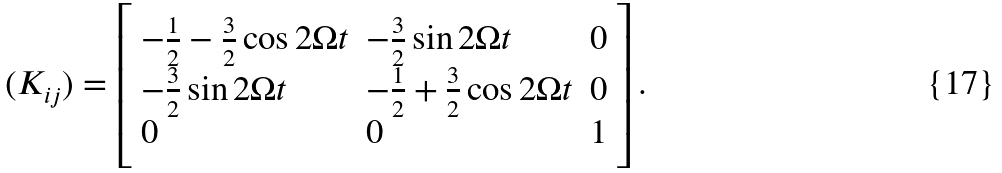<formula> <loc_0><loc_0><loc_500><loc_500>( K _ { i j } ) = \left [ \begin{array} { l l l } - \frac { 1 } { 2 } - \frac { 3 } { 2 } \cos { 2 \Omega t } & - \frac { 3 } { 2 } \sin { 2 \Omega t } & 0 \\ - \frac { 3 } { 2 } \sin { 2 \Omega t } & - \frac { 1 } { 2 } + \frac { 3 } { 2 } \cos { 2 \Omega t } & 0 \\ 0 & 0 & 1 \end{array} \right ] .</formula> 